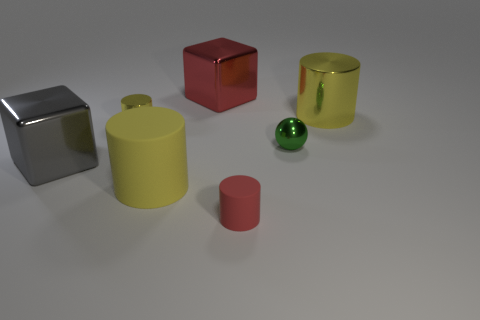There is another big object that is the same shape as the large red shiny object; what is its color?
Offer a very short reply. Gray. There is another tiny thing that is made of the same material as the small green thing; what color is it?
Keep it short and to the point. Yellow. What is the material of the tiny object that is the same color as the large rubber cylinder?
Provide a succinct answer. Metal. What material is the red thing that is the same size as the gray metal object?
Your response must be concise. Metal. Are there any green matte blocks that have the same size as the red metal object?
Provide a short and direct response. No. The big matte object is what color?
Provide a succinct answer. Yellow. What color is the big matte cylinder behind the small red rubber thing in front of the ball?
Keep it short and to the point. Yellow. There is a yellow metallic thing that is left of the tiny cylinder in front of the big cube that is in front of the green shiny object; what is its shape?
Offer a very short reply. Cylinder. What number of gray blocks are the same material as the big gray object?
Offer a terse response. 0. How many large yellow cylinders are to the right of the metal cube behind the gray block?
Your response must be concise. 1. 